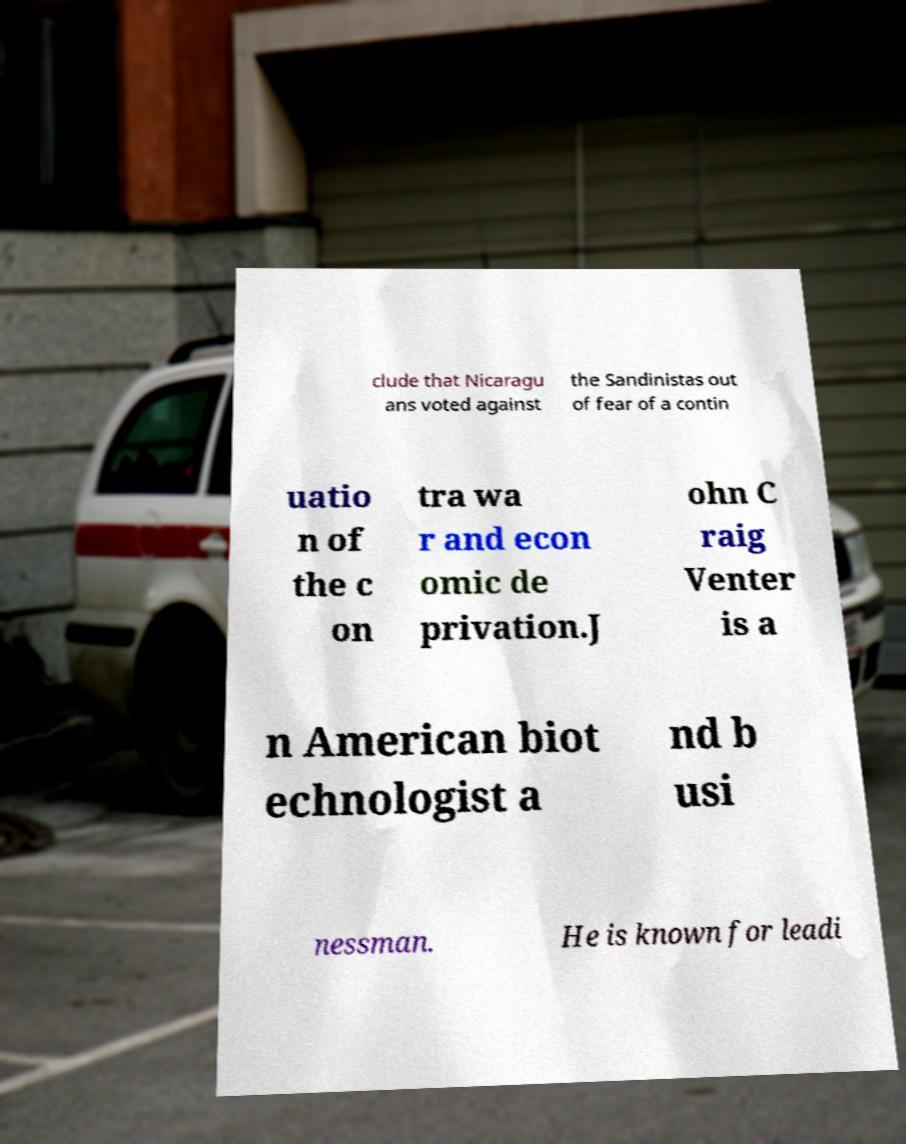Can you accurately transcribe the text from the provided image for me? clude that Nicaragu ans voted against the Sandinistas out of fear of a contin uatio n of the c on tra wa r and econ omic de privation.J ohn C raig Venter is a n American biot echnologist a nd b usi nessman. He is known for leadi 